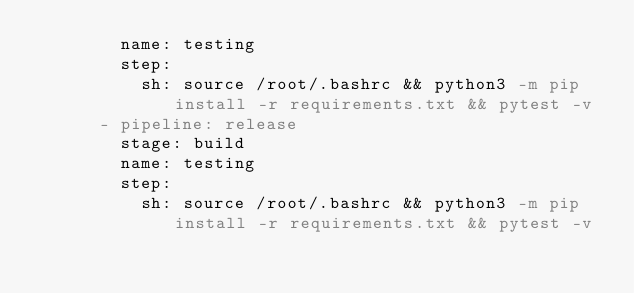<code> <loc_0><loc_0><loc_500><loc_500><_YAML_>        name: testing
        step:
          sh: source /root/.bashrc && python3 -m pip install -r requirements.txt && pytest -v
      - pipeline: release
        stage: build
        name: testing
        step:
          sh: source /root/.bashrc && python3 -m pip install -r requirements.txt && pytest -v
</code> 